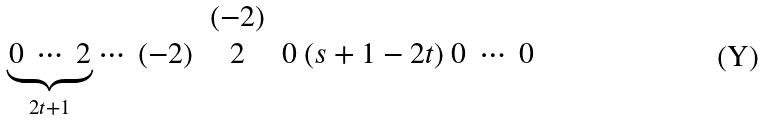<formula> <loc_0><loc_0><loc_500><loc_500>\begin{matrix} & ( - 2 ) & \\ \underbrace { 0 \ \cdots \ 2 } _ { 2 t + 1 } \cdots \ ( - 2 ) & 2 & 0 \ ( s + 1 - 2 t ) \ 0 \ \cdots \ 0 \end{matrix}</formula> 